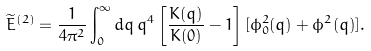<formula> <loc_0><loc_0><loc_500><loc_500>\widetilde { E } ^ { ( 2 ) } = \frac { 1 } { 4 \pi ^ { 2 } } \int _ { 0 } ^ { \infty } d q \, q ^ { 4 } \left [ \frac { K ( q ) } { K ( 0 ) } - 1 \right ] [ \phi _ { 0 } ^ { 2 } ( q ) + \phi ^ { 2 } ( q ) ] .</formula> 